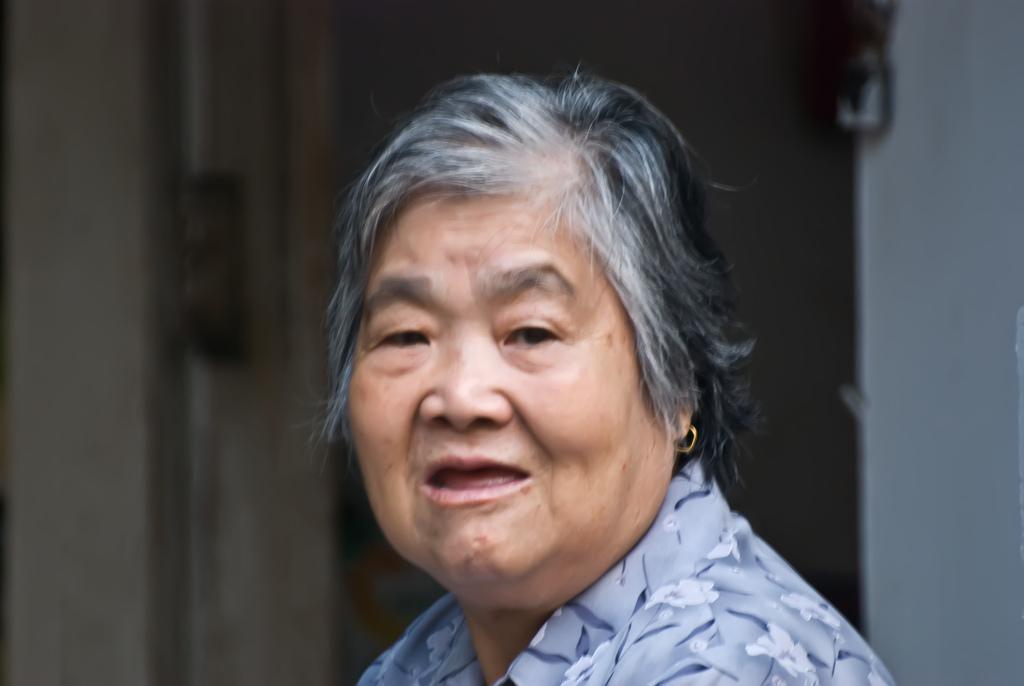Describe this image in one or two sentences. In the image we can see a woman. Behind her there is a wall. 